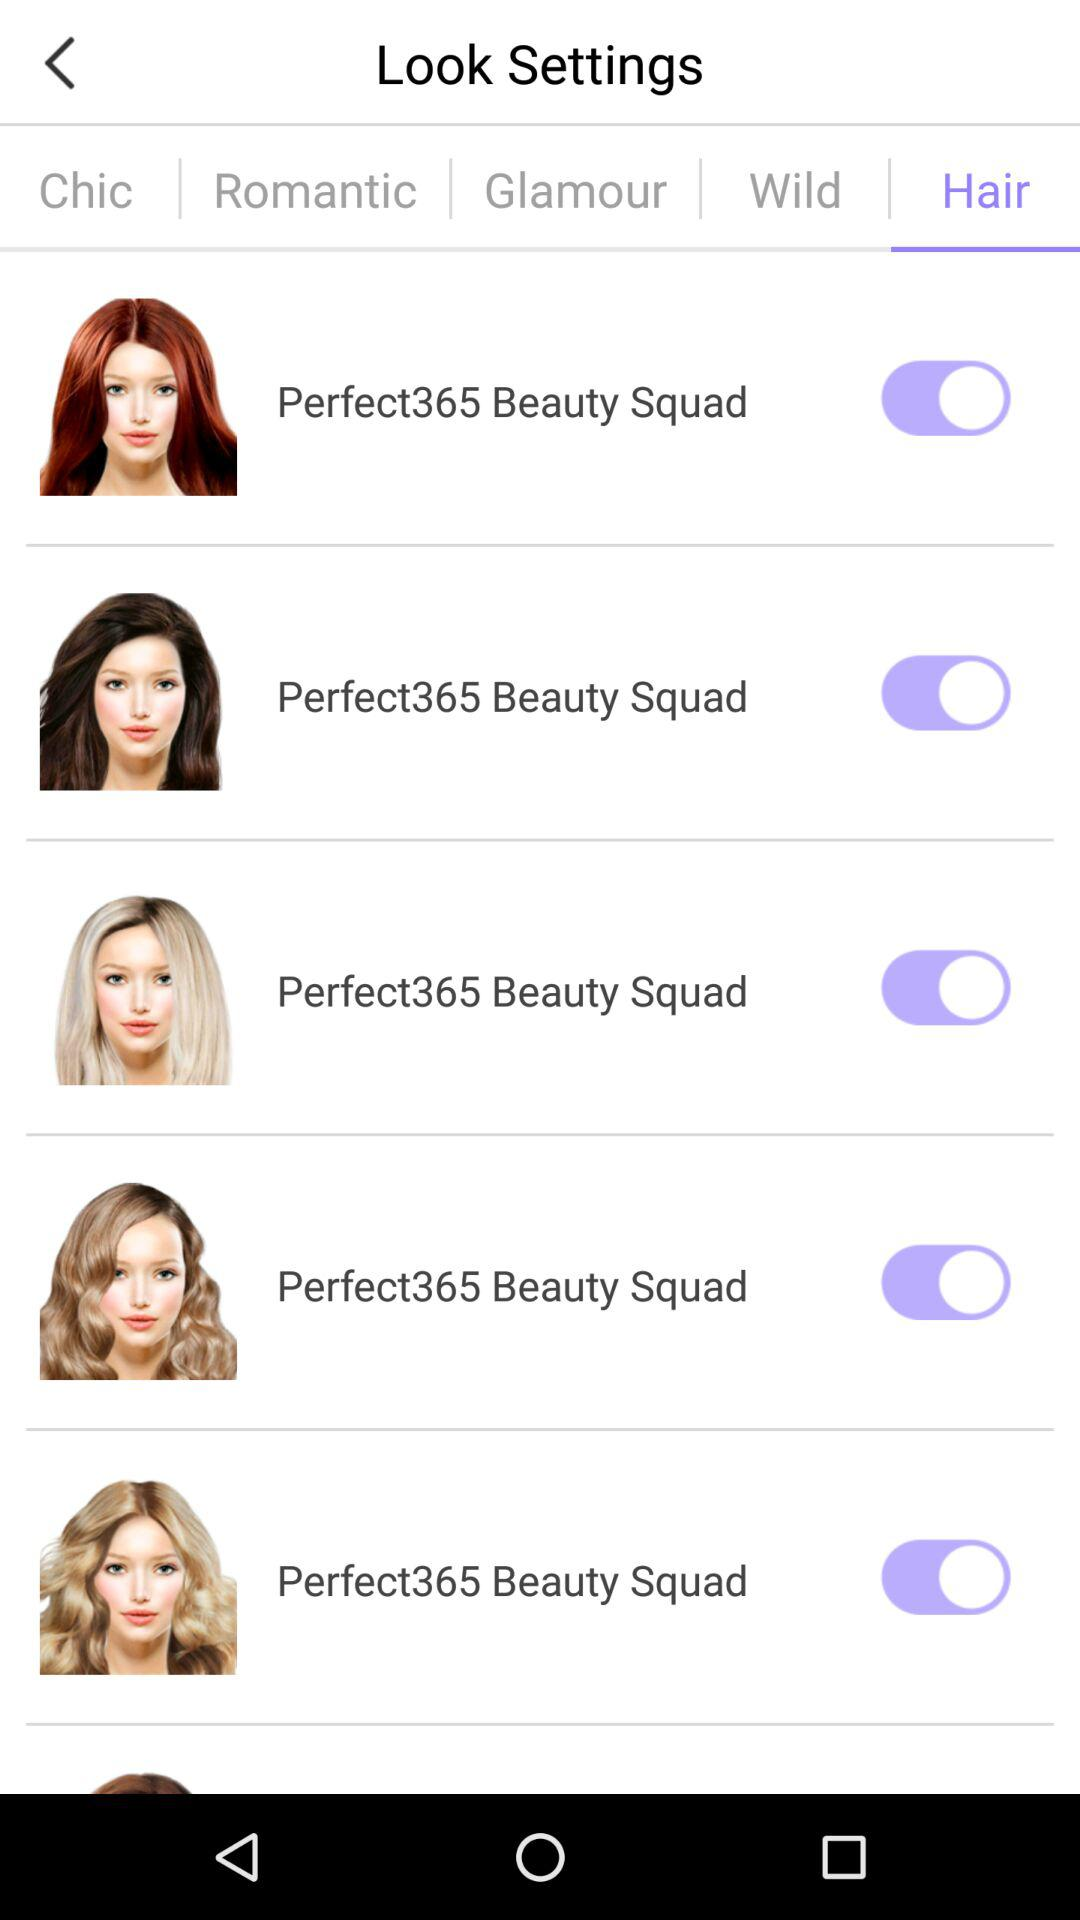Which tab is currently selected? The currently selected tab is "Hair". 